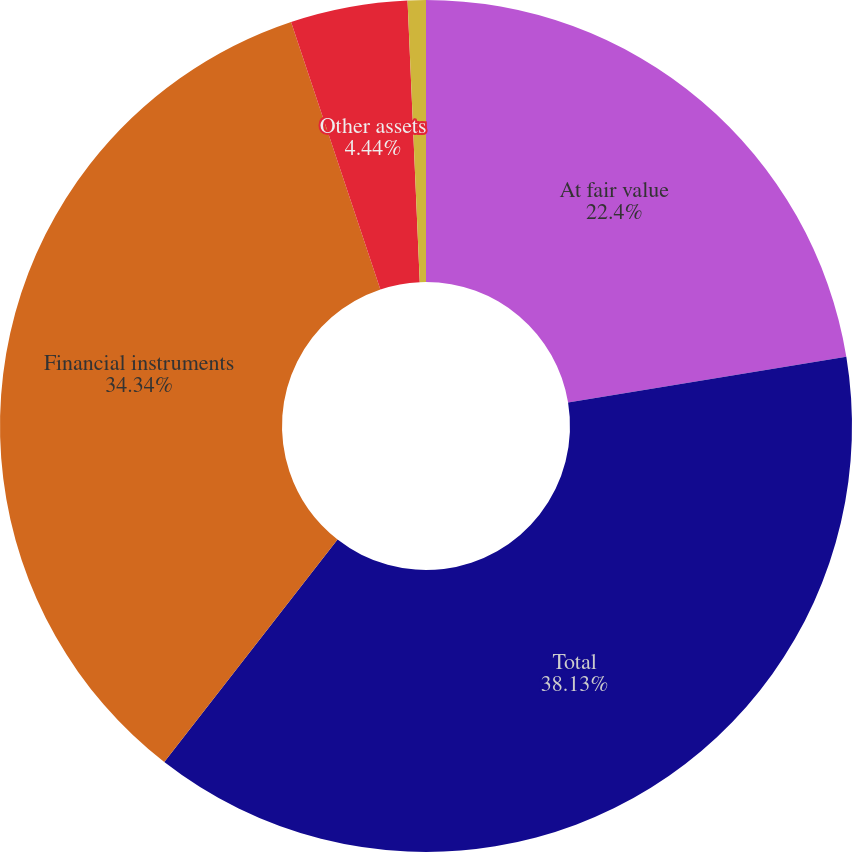Convert chart to OTSL. <chart><loc_0><loc_0><loc_500><loc_500><pie_chart><fcel>At fair value<fcel>Total<fcel>Financial instruments<fcel>Other assets<fcel>At amortized cost<nl><fcel>22.4%<fcel>38.13%<fcel>34.34%<fcel>4.44%<fcel>0.69%<nl></chart> 